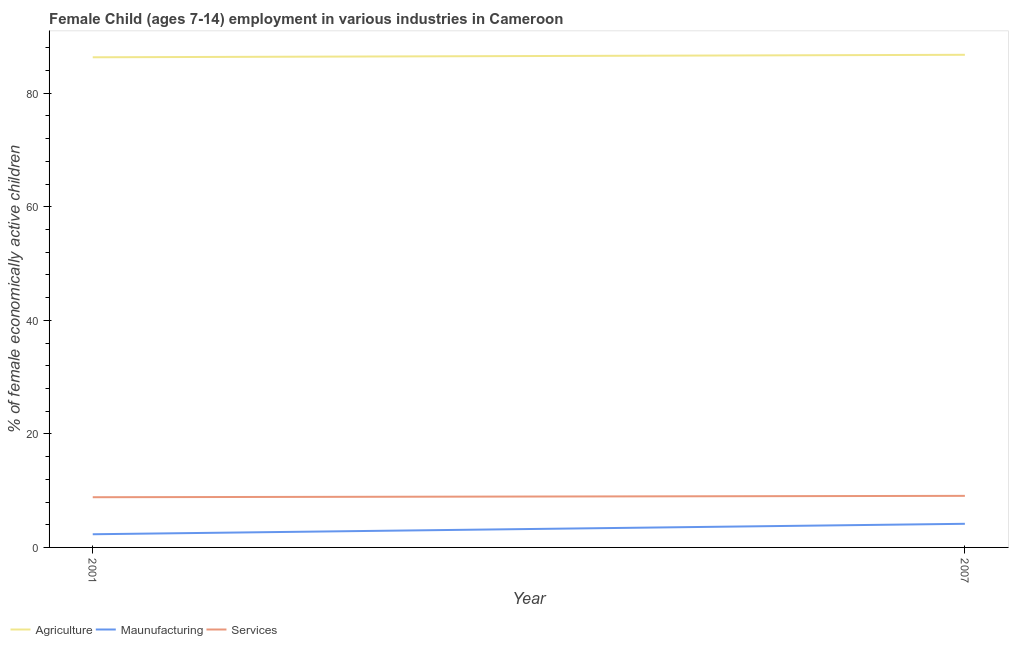Does the line corresponding to percentage of economically active children in manufacturing intersect with the line corresponding to percentage of economically active children in services?
Give a very brief answer. No. Is the number of lines equal to the number of legend labels?
Your answer should be compact. Yes. What is the percentage of economically active children in agriculture in 2007?
Offer a terse response. 86.76. Across all years, what is the maximum percentage of economically active children in manufacturing?
Provide a short and direct response. 4.16. Across all years, what is the minimum percentage of economically active children in manufacturing?
Your answer should be very brief. 2.32. In which year was the percentage of economically active children in agriculture maximum?
Your response must be concise. 2007. What is the total percentage of economically active children in agriculture in the graph?
Provide a succinct answer. 173.08. What is the difference between the percentage of economically active children in manufacturing in 2001 and that in 2007?
Provide a succinct answer. -1.84. What is the difference between the percentage of economically active children in services in 2007 and the percentage of economically active children in manufacturing in 2001?
Offer a very short reply. 6.76. What is the average percentage of economically active children in services per year?
Ensure brevity in your answer.  8.96. What is the ratio of the percentage of economically active children in services in 2001 to that in 2007?
Your response must be concise. 0.97. In how many years, is the percentage of economically active children in services greater than the average percentage of economically active children in services taken over all years?
Make the answer very short. 1. Does the percentage of economically active children in agriculture monotonically increase over the years?
Give a very brief answer. Yes. Is the percentage of economically active children in services strictly greater than the percentage of economically active children in manufacturing over the years?
Your answer should be very brief. Yes. Is the percentage of economically active children in manufacturing strictly less than the percentage of economically active children in agriculture over the years?
Provide a succinct answer. Yes. How many years are there in the graph?
Make the answer very short. 2. Does the graph contain any zero values?
Ensure brevity in your answer.  No. Does the graph contain grids?
Your answer should be very brief. No. What is the title of the graph?
Ensure brevity in your answer.  Female Child (ages 7-14) employment in various industries in Cameroon. Does "Communicable diseases" appear as one of the legend labels in the graph?
Make the answer very short. No. What is the label or title of the X-axis?
Make the answer very short. Year. What is the label or title of the Y-axis?
Make the answer very short. % of female economically active children. What is the % of female economically active children in Agriculture in 2001?
Make the answer very short. 86.32. What is the % of female economically active children in Maunufacturing in 2001?
Make the answer very short. 2.32. What is the % of female economically active children of Services in 2001?
Provide a succinct answer. 8.84. What is the % of female economically active children in Agriculture in 2007?
Offer a very short reply. 86.76. What is the % of female economically active children in Maunufacturing in 2007?
Ensure brevity in your answer.  4.16. What is the % of female economically active children of Services in 2007?
Your answer should be very brief. 9.08. Across all years, what is the maximum % of female economically active children in Agriculture?
Offer a very short reply. 86.76. Across all years, what is the maximum % of female economically active children of Maunufacturing?
Your answer should be very brief. 4.16. Across all years, what is the maximum % of female economically active children of Services?
Provide a short and direct response. 9.08. Across all years, what is the minimum % of female economically active children in Agriculture?
Ensure brevity in your answer.  86.32. Across all years, what is the minimum % of female economically active children in Maunufacturing?
Ensure brevity in your answer.  2.32. Across all years, what is the minimum % of female economically active children of Services?
Offer a very short reply. 8.84. What is the total % of female economically active children in Agriculture in the graph?
Make the answer very short. 173.08. What is the total % of female economically active children of Maunufacturing in the graph?
Offer a very short reply. 6.48. What is the total % of female economically active children in Services in the graph?
Offer a very short reply. 17.92. What is the difference between the % of female economically active children in Agriculture in 2001 and that in 2007?
Offer a terse response. -0.44. What is the difference between the % of female economically active children in Maunufacturing in 2001 and that in 2007?
Provide a short and direct response. -1.84. What is the difference between the % of female economically active children in Services in 2001 and that in 2007?
Ensure brevity in your answer.  -0.24. What is the difference between the % of female economically active children in Agriculture in 2001 and the % of female economically active children in Maunufacturing in 2007?
Give a very brief answer. 82.16. What is the difference between the % of female economically active children in Agriculture in 2001 and the % of female economically active children in Services in 2007?
Provide a short and direct response. 77.24. What is the difference between the % of female economically active children of Maunufacturing in 2001 and the % of female economically active children of Services in 2007?
Provide a short and direct response. -6.76. What is the average % of female economically active children in Agriculture per year?
Your answer should be compact. 86.54. What is the average % of female economically active children of Maunufacturing per year?
Keep it short and to the point. 3.24. What is the average % of female economically active children of Services per year?
Provide a short and direct response. 8.96. In the year 2001, what is the difference between the % of female economically active children of Agriculture and % of female economically active children of Maunufacturing?
Provide a short and direct response. 84. In the year 2001, what is the difference between the % of female economically active children in Agriculture and % of female economically active children in Services?
Give a very brief answer. 77.48. In the year 2001, what is the difference between the % of female economically active children of Maunufacturing and % of female economically active children of Services?
Keep it short and to the point. -6.52. In the year 2007, what is the difference between the % of female economically active children of Agriculture and % of female economically active children of Maunufacturing?
Offer a very short reply. 82.6. In the year 2007, what is the difference between the % of female economically active children in Agriculture and % of female economically active children in Services?
Your answer should be compact. 77.68. In the year 2007, what is the difference between the % of female economically active children in Maunufacturing and % of female economically active children in Services?
Make the answer very short. -4.92. What is the ratio of the % of female economically active children in Agriculture in 2001 to that in 2007?
Keep it short and to the point. 0.99. What is the ratio of the % of female economically active children in Maunufacturing in 2001 to that in 2007?
Ensure brevity in your answer.  0.56. What is the ratio of the % of female economically active children of Services in 2001 to that in 2007?
Provide a succinct answer. 0.97. What is the difference between the highest and the second highest % of female economically active children of Agriculture?
Make the answer very short. 0.44. What is the difference between the highest and the second highest % of female economically active children in Maunufacturing?
Ensure brevity in your answer.  1.84. What is the difference between the highest and the second highest % of female economically active children in Services?
Offer a very short reply. 0.24. What is the difference between the highest and the lowest % of female economically active children in Agriculture?
Your answer should be compact. 0.44. What is the difference between the highest and the lowest % of female economically active children in Maunufacturing?
Offer a very short reply. 1.84. What is the difference between the highest and the lowest % of female economically active children in Services?
Your response must be concise. 0.24. 